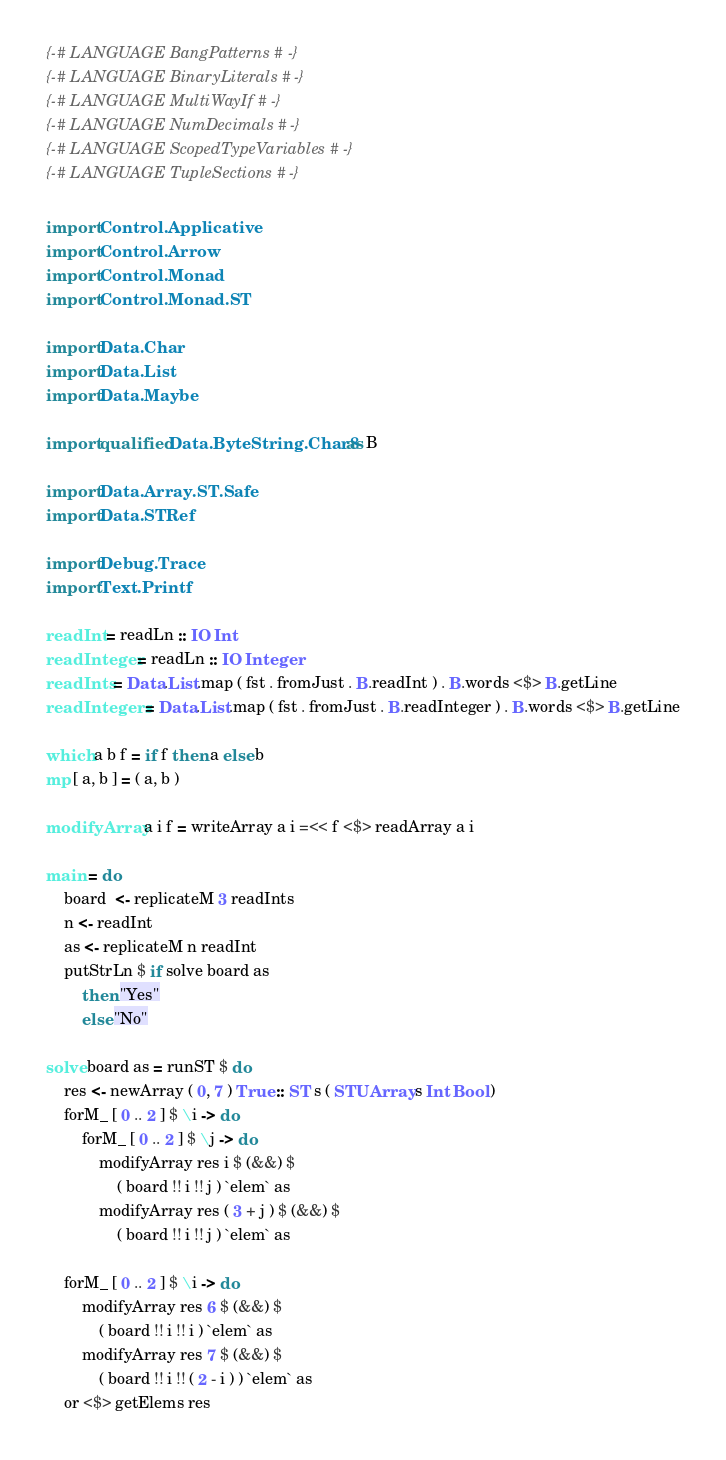Convert code to text. <code><loc_0><loc_0><loc_500><loc_500><_Haskell_>{-# LANGUAGE BangPatterns #-}
{-# LANGUAGE BinaryLiterals #-}
{-# LANGUAGE MultiWayIf #-}
{-# LANGUAGE NumDecimals #-}
{-# LANGUAGE ScopedTypeVariables #-}
{-# LANGUAGE TupleSections #-}

import Control.Applicative
import Control.Arrow
import Control.Monad
import Control.Monad.ST

import Data.Char
import Data.List
import Data.Maybe

import qualified Data.ByteString.Char8 as B

import Data.Array.ST.Safe
import Data.STRef

import Debug.Trace
import Text.Printf

readInt = readLn :: IO Int
readInteger = readLn :: IO Integer
readInts = Data.List.map ( fst . fromJust . B.readInt ) . B.words <$> B.getLine
readIntegers = Data.List.map ( fst . fromJust . B.readInteger ) . B.words <$> B.getLine

which a b f = if f then a else b
mp [ a, b ] = ( a, b )

modifyArray a i f = writeArray a i =<< f <$> readArray a i

main = do
	board  <- replicateM 3 readInts
	n <- readInt
	as <- replicateM n readInt
	putStrLn $ if solve board as
		then "Yes"
		else "No"
	
solve board as = runST $ do
	res <- newArray ( 0, 7 ) True :: ST s ( STUArray s Int Bool )
	forM_ [ 0 .. 2 ] $ \i -> do
		forM_ [ 0 .. 2 ] $ \j -> do
			modifyArray res i $ (&&) $
				( board !! i !! j ) `elem` as
			modifyArray res ( 3 + j ) $ (&&) $
				( board !! i !! j ) `elem` as

	forM_ [ 0 .. 2 ] $ \i -> do
		modifyArray res 6 $ (&&) $
			( board !! i !! i ) `elem` as
		modifyArray res 7 $ (&&) $
			( board !! i !! ( 2 - i ) ) `elem` as
	or <$> getElems res</code> 